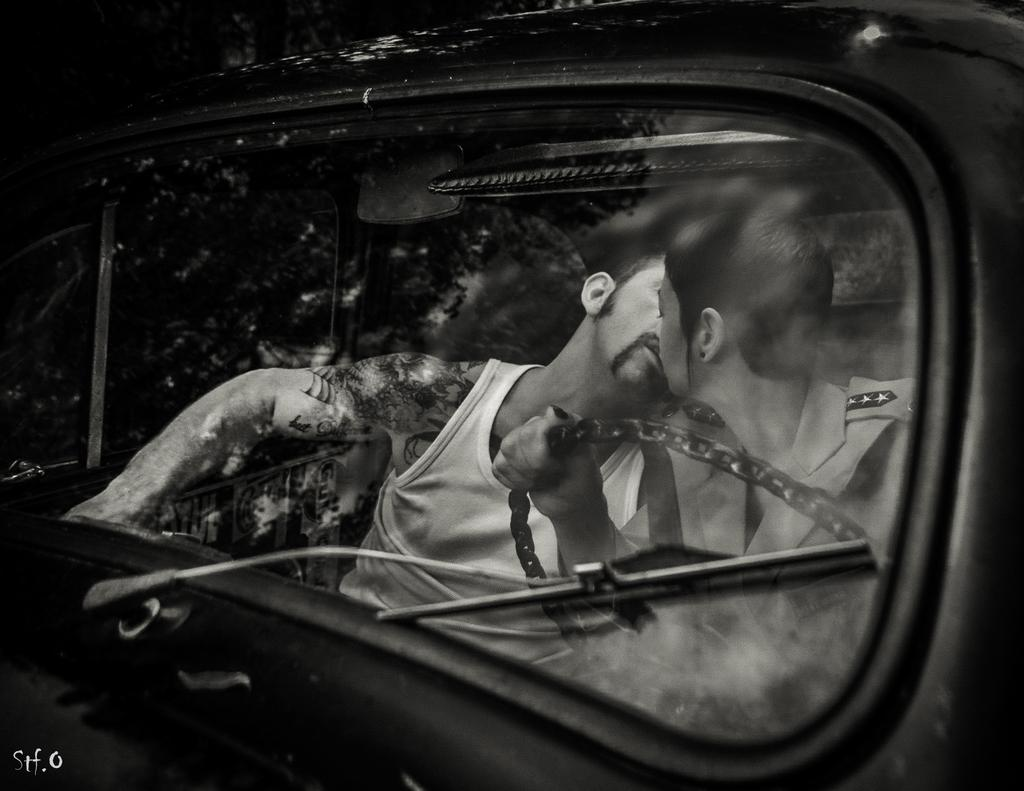What is the main subject of the image? The main subject of the image is a car. Are there any people in the image? Yes, there are two persons sitting on the car. What is one person doing in the image? One person is holding the steering wheel of the car. What type of sink can be seen in the image? There is no sink present in the image; it features a car with two people sitting on it. 